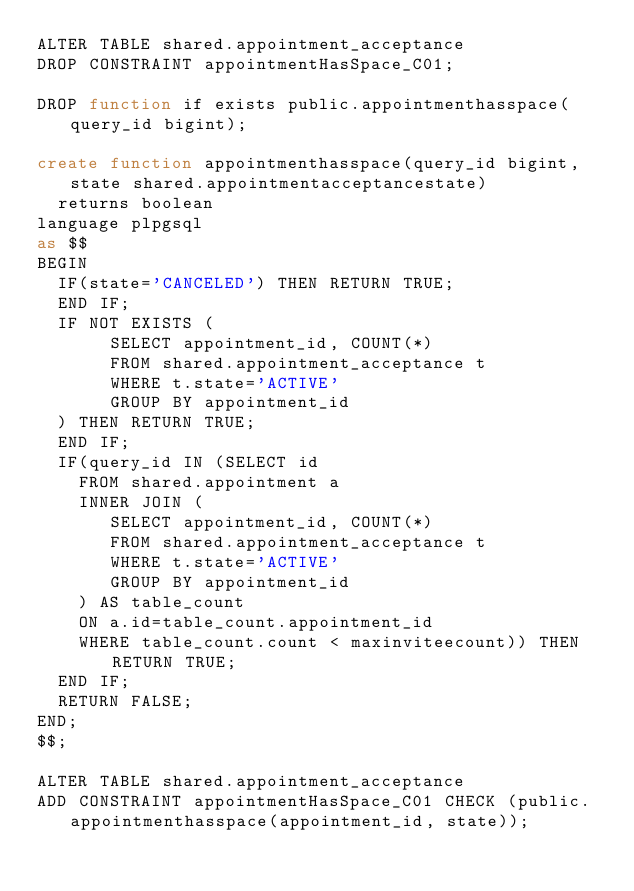<code> <loc_0><loc_0><loc_500><loc_500><_SQL_>ALTER TABLE shared.appointment_acceptance
DROP CONSTRAINT appointmentHasSpace_C01;

DROP function if exists public.appointmenthasspace(query_id bigint);

create function appointmenthasspace(query_id bigint, state shared.appointmentacceptancestate)
  returns boolean
language plpgsql
as $$
BEGIN
  IF(state='CANCELED') THEN RETURN TRUE;
  END IF;
  IF NOT EXISTS (
       SELECT appointment_id, COUNT(*)
       FROM shared.appointment_acceptance t
       WHERE t.state='ACTIVE'
       GROUP BY appointment_id
  ) THEN RETURN TRUE;
  END IF;
  IF(query_id IN (SELECT id
    FROM shared.appointment a
    INNER JOIN (
       SELECT appointment_id, COUNT(*)
       FROM shared.appointment_acceptance t
       WHERE t.state='ACTIVE'
       GROUP BY appointment_id
    ) AS table_count
    ON a.id=table_count.appointment_id
    WHERE table_count.count < maxinviteecount)) THEN RETURN TRUE;
  END IF;
  RETURN FALSE;
END;
$$;

ALTER TABLE shared.appointment_acceptance
ADD CONSTRAINT appointmentHasSpace_C01 CHECK (public.appointmenthasspace(appointment_id, state));
</code> 